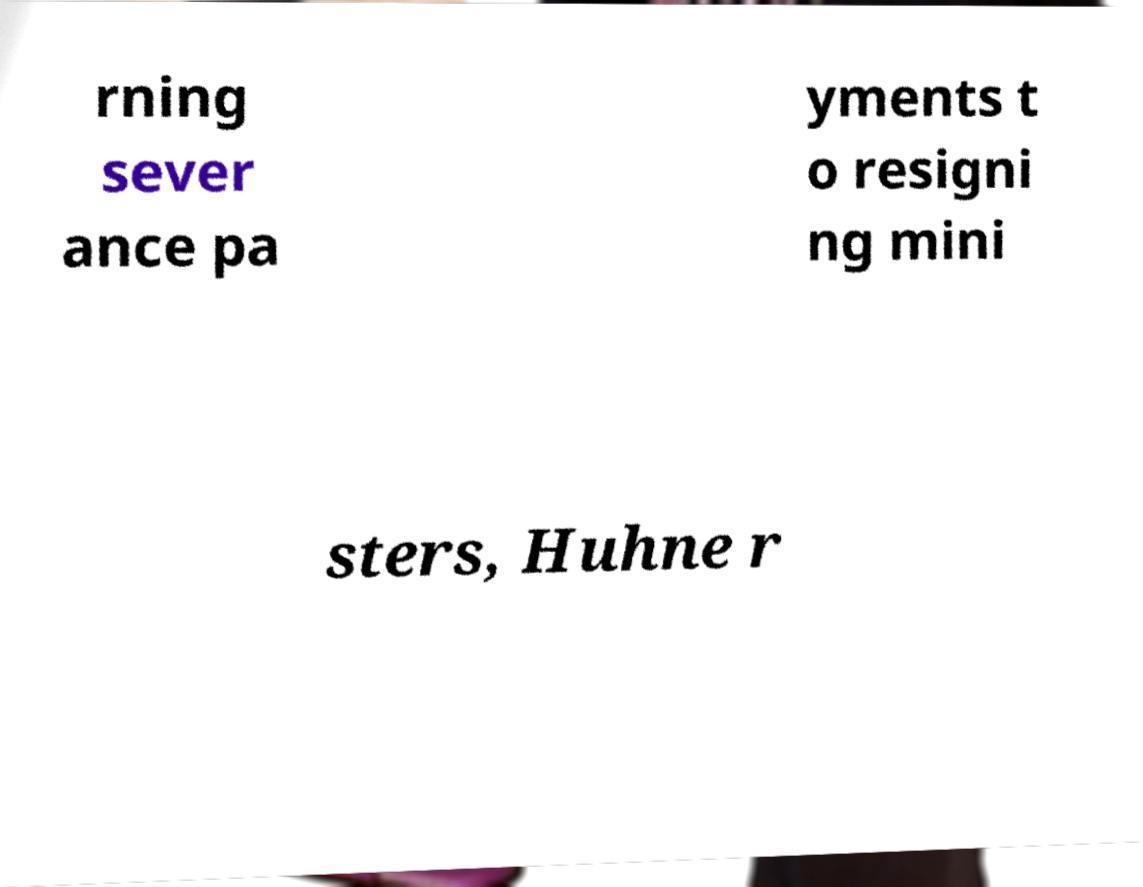I need the written content from this picture converted into text. Can you do that? rning sever ance pa yments t o resigni ng mini sters, Huhne r 